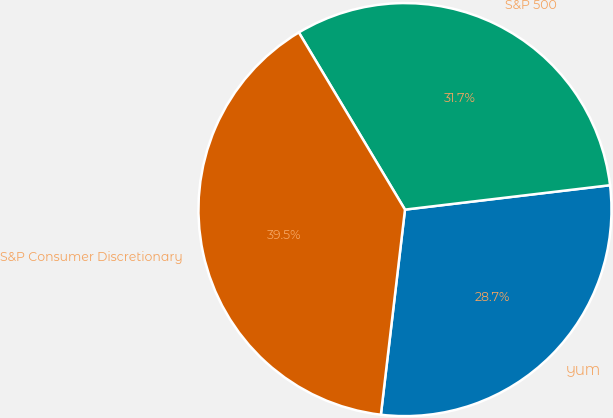<chart> <loc_0><loc_0><loc_500><loc_500><pie_chart><fcel>YUM<fcel>S&P 500<fcel>S&P Consumer Discretionary<nl><fcel>28.75%<fcel>31.71%<fcel>39.55%<nl></chart> 